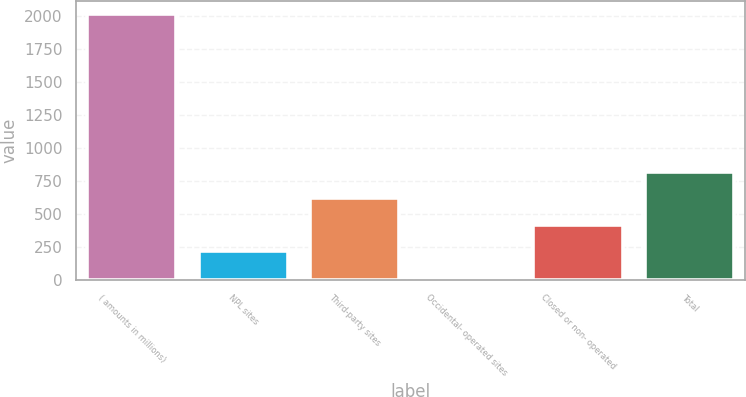Convert chart to OTSL. <chart><loc_0><loc_0><loc_500><loc_500><bar_chart><fcel>( amounts in millions)<fcel>NPL sites<fcel>Third-party sites<fcel>Occidental- operated sites<fcel>Closed or non- operated<fcel>Total<nl><fcel>2013<fcel>219.3<fcel>617.9<fcel>20<fcel>418.6<fcel>817.2<nl></chart> 